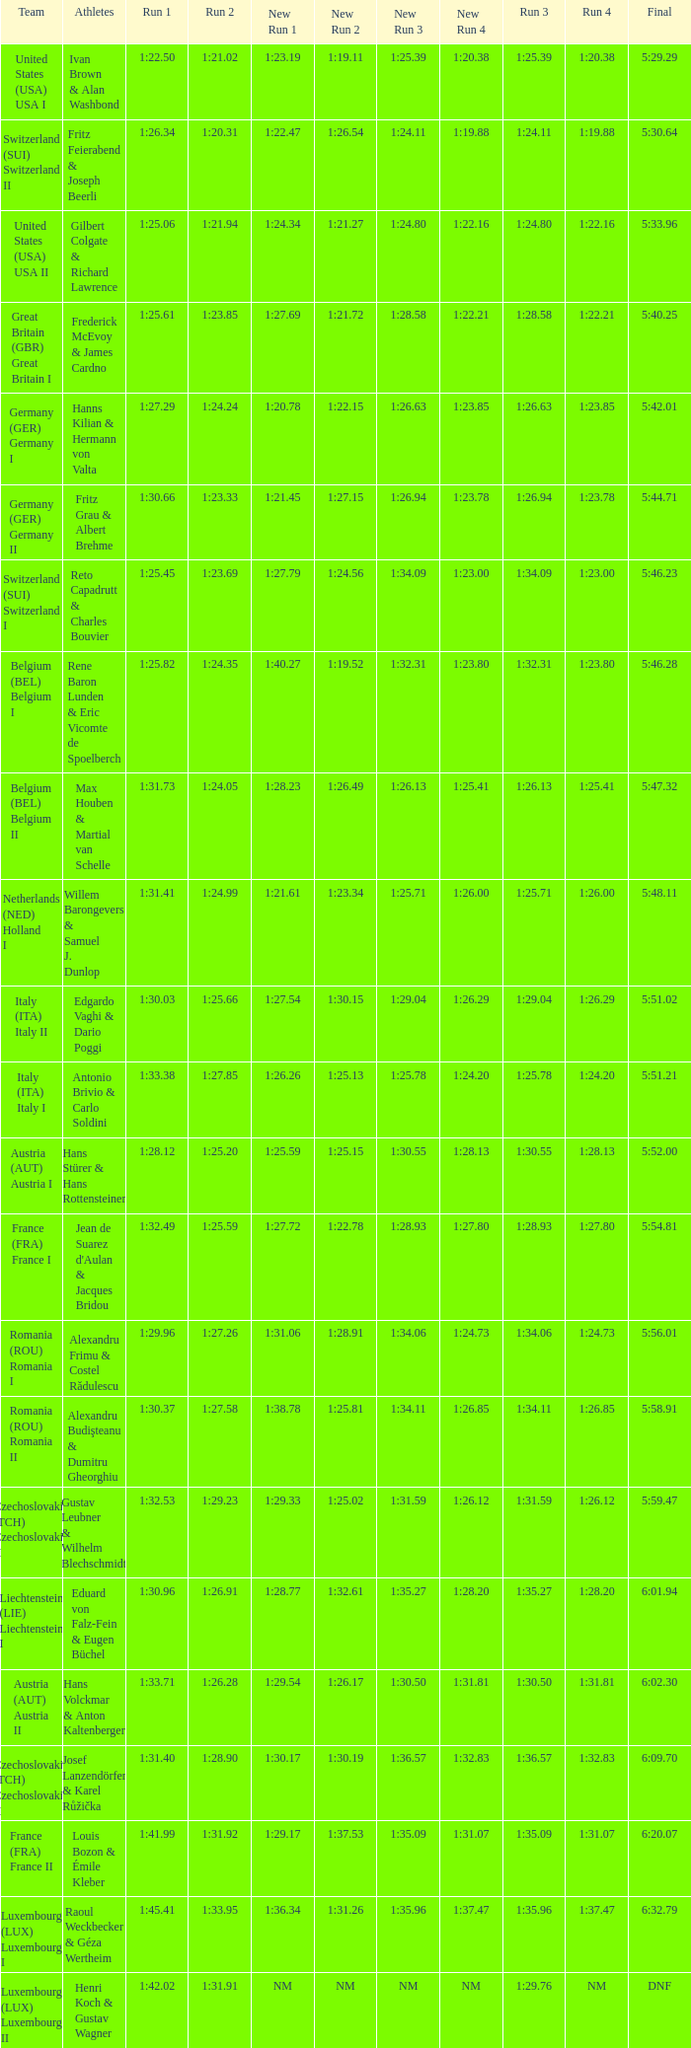Parse the table in full. {'header': ['Team', 'Athletes', 'Run 1', 'Run 2', 'New Run 1', 'New Run 2', 'New Run 3', 'New Run 4', 'Run 3', 'Run 4', 'Final'], 'rows': [['United States (USA) USA I', 'Ivan Brown & Alan Washbond', '1:22.50', '1:21.02', '1:23.19', '1:19.11', '1:25.39', '1:20.38', '1:25.39', '1:20.38', '5:29.29'], ['Switzerland (SUI) Switzerland II', 'Fritz Feierabend & Joseph Beerli', '1:26.34', '1:20.31', '1:22.47', '1:26.54', '1:24.11', '1:19.88', '1:24.11', '1:19.88', '5:30.64'], ['United States (USA) USA II', 'Gilbert Colgate & Richard Lawrence', '1:25.06', '1:21.94', '1:24.34', '1:21.27', '1:24.80', '1:22.16', '1:24.80', '1:22.16', '5:33.96'], ['Great Britain (GBR) Great Britain I', 'Frederick McEvoy & James Cardno', '1:25.61', '1:23.85', '1:27.69', '1:21.72', '1:28.58', '1:22.21', '1:28.58', '1:22.21', '5:40.25'], ['Germany (GER) Germany I', 'Hanns Kilian & Hermann von Valta', '1:27.29', '1:24.24', '1:20.78', '1:22.15', '1:26.63', '1:23.85', '1:26.63', '1:23.85', '5:42.01'], ['Germany (GER) Germany II', 'Fritz Grau & Albert Brehme', '1:30.66', '1:23.33', '1:21.45', '1:27.15', '1:26.94', '1:23.78', '1:26.94', '1:23.78', '5:44.71'], ['Switzerland (SUI) Switzerland I', 'Reto Capadrutt & Charles Bouvier', '1:25.45', '1:23.69', '1:27.79', '1:24.56', '1:34.09', '1:23.00', '1:34.09', '1:23.00', '5:46.23'], ['Belgium (BEL) Belgium I', 'Rene Baron Lunden & Eric Vicomte de Spoelberch', '1:25.82', '1:24.35', '1:40.27', '1:19.52', '1:32.31', '1:23.80', '1:32.31', '1:23.80', '5:46.28'], ['Belgium (BEL) Belgium II', 'Max Houben & Martial van Schelle', '1:31.73', '1:24.05', '1:28.23', '1:26.49', '1:26.13', '1:25.41', '1:26.13', '1:25.41', '5:47.32'], ['Netherlands (NED) Holland I', 'Willem Barongevers & Samuel J. Dunlop', '1:31.41', '1:24.99', '1:21.61', '1:23.34', '1:25.71', '1:26.00', '1:25.71', '1:26.00', '5:48.11'], ['Italy (ITA) Italy II', 'Edgardo Vaghi & Dario Poggi', '1:30.03', '1:25.66', '1:27.54', '1:30.15', '1:29.04', '1:26.29', '1:29.04', '1:26.29', '5:51.02'], ['Italy (ITA) Italy I', 'Antonio Brivio & Carlo Soldini', '1:33.38', '1:27.85', '1:26.26', '1:25.13', '1:25.78', '1:24.20', '1:25.78', '1:24.20', '5:51.21'], ['Austria (AUT) Austria I', 'Hans Stürer & Hans Rottensteiner', '1:28.12', '1:25.20', '1:25.59', '1:25.15', '1:30.55', '1:28.13', '1:30.55', '1:28.13', '5:52.00'], ['France (FRA) France I', "Jean de Suarez d'Aulan & Jacques Bridou", '1:32.49', '1:25.59', '1:27.72', '1:22.78', '1:28.93', '1:27.80', '1:28.93', '1:27.80', '5:54.81'], ['Romania (ROU) Romania I', 'Alexandru Frimu & Costel Rădulescu', '1:29.96', '1:27.26', '1:31.06', '1:28.91', '1:34.06', '1:24.73', '1:34.06', '1:24.73', '5:56.01'], ['Romania (ROU) Romania II', 'Alexandru Budişteanu & Dumitru Gheorghiu', '1:30.37', '1:27.58', '1:38.78', '1:25.81', '1:34.11', '1:26.85', '1:34.11', '1:26.85', '5:58.91'], ['Czechoslovakia (TCH) Czechoslovakia II', 'Gustav Leubner & Wilhelm Blechschmidt', '1:32.53', '1:29.23', '1:29.33', '1:25.02', '1:31.59', '1:26.12', '1:31.59', '1:26.12', '5:59.47'], ['Liechtenstein (LIE) Liechtenstein I', 'Eduard von Falz-Fein & Eugen Büchel', '1:30.96', '1:26.91', '1:28.77', '1:32.61', '1:35.27', '1:28.20', '1:35.27', '1:28.20', '6:01.94'], ['Austria (AUT) Austria II', 'Hans Volckmar & Anton Kaltenberger', '1:33.71', '1:26.28', '1:29.54', '1:26.17', '1:30.50', '1:31.81', '1:30.50', '1:31.81', '6:02.30'], ['Czechoslovakia (TCH) Czechoslovakia II', 'Josef Lanzendörfer & Karel Růžička', '1:31.40', '1:28.90', '1:30.17', '1:30.19', '1:36.57', '1:32.83', '1:36.57', '1:32.83', '6:09.70'], ['France (FRA) France II', 'Louis Bozon & Émile Kleber', '1:41.99', '1:31.92', '1:29.17', '1:37.53', '1:35.09', '1:31.07', '1:35.09', '1:31.07', '6:20.07'], ['Luxembourg (LUX) Luxembourg I', 'Raoul Weckbecker & Géza Wertheim', '1:45.41', '1:33.95', '1:36.34', '1:31.26', '1:35.96', '1:37.47', '1:35.96', '1:37.47', '6:32.79'], ['Luxembourg (LUX) Luxembourg II', 'Henri Koch & Gustav Wagner', '1:42.02', '1:31.91', 'NM', 'NM', 'NM', 'NM', '1:29.76', 'NM', 'DNF']]} Which Run 4 has a Run 3 of 1:26.63? 1:23.85. 